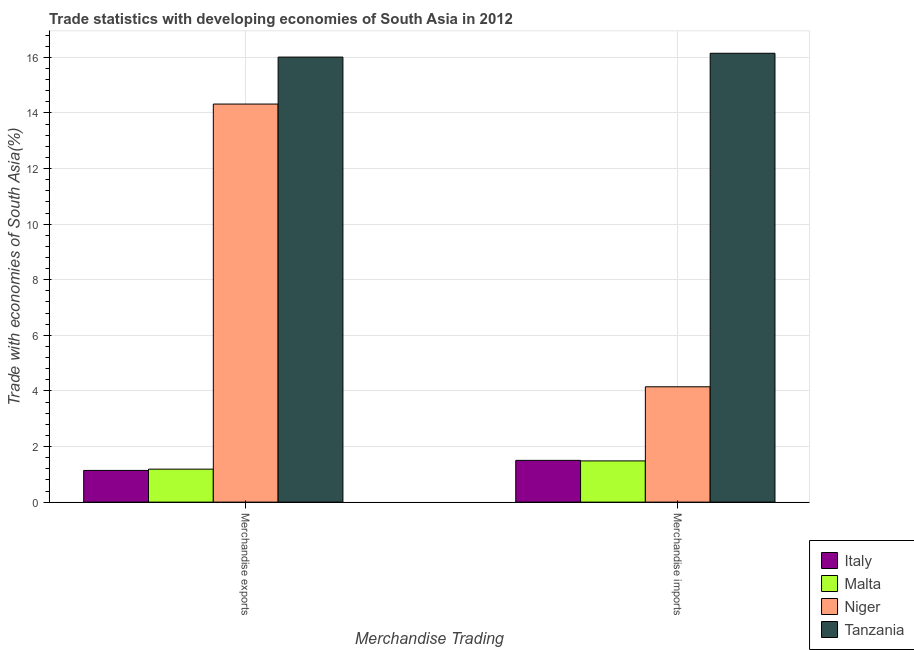How many different coloured bars are there?
Your response must be concise. 4. How many groups of bars are there?
Make the answer very short. 2. Are the number of bars per tick equal to the number of legend labels?
Give a very brief answer. Yes. Are the number of bars on each tick of the X-axis equal?
Give a very brief answer. Yes. How many bars are there on the 2nd tick from the left?
Offer a terse response. 4. How many bars are there on the 2nd tick from the right?
Offer a very short reply. 4. What is the merchandise exports in Tanzania?
Your answer should be very brief. 16.01. Across all countries, what is the maximum merchandise exports?
Provide a succinct answer. 16.01. Across all countries, what is the minimum merchandise exports?
Provide a short and direct response. 1.14. In which country was the merchandise imports maximum?
Your answer should be very brief. Tanzania. In which country was the merchandise imports minimum?
Offer a terse response. Malta. What is the total merchandise exports in the graph?
Provide a succinct answer. 32.66. What is the difference between the merchandise imports in Tanzania and that in Niger?
Keep it short and to the point. 12. What is the difference between the merchandise exports in Niger and the merchandise imports in Tanzania?
Keep it short and to the point. -1.83. What is the average merchandise imports per country?
Your response must be concise. 5.82. What is the difference between the merchandise exports and merchandise imports in Tanzania?
Ensure brevity in your answer.  -0.14. In how many countries, is the merchandise exports greater than 6.8 %?
Make the answer very short. 2. What is the ratio of the merchandise imports in Tanzania to that in Malta?
Provide a succinct answer. 10.89. In how many countries, is the merchandise imports greater than the average merchandise imports taken over all countries?
Provide a short and direct response. 1. What does the 4th bar from the left in Merchandise imports represents?
Offer a very short reply. Tanzania. What does the 3rd bar from the right in Merchandise exports represents?
Keep it short and to the point. Malta. What is the difference between two consecutive major ticks on the Y-axis?
Offer a terse response. 2. Are the values on the major ticks of Y-axis written in scientific E-notation?
Offer a terse response. No. Does the graph contain any zero values?
Make the answer very short. No. Does the graph contain grids?
Make the answer very short. Yes. How many legend labels are there?
Your answer should be very brief. 4. How are the legend labels stacked?
Offer a terse response. Vertical. What is the title of the graph?
Make the answer very short. Trade statistics with developing economies of South Asia in 2012. Does "Azerbaijan" appear as one of the legend labels in the graph?
Offer a terse response. No. What is the label or title of the X-axis?
Offer a very short reply. Merchandise Trading. What is the label or title of the Y-axis?
Offer a very short reply. Trade with economies of South Asia(%). What is the Trade with economies of South Asia(%) of Italy in Merchandise exports?
Give a very brief answer. 1.14. What is the Trade with economies of South Asia(%) in Malta in Merchandise exports?
Your response must be concise. 1.19. What is the Trade with economies of South Asia(%) of Niger in Merchandise exports?
Provide a short and direct response. 14.32. What is the Trade with economies of South Asia(%) in Tanzania in Merchandise exports?
Give a very brief answer. 16.01. What is the Trade with economies of South Asia(%) of Italy in Merchandise imports?
Ensure brevity in your answer.  1.5. What is the Trade with economies of South Asia(%) in Malta in Merchandise imports?
Make the answer very short. 1.48. What is the Trade with economies of South Asia(%) of Niger in Merchandise imports?
Offer a very short reply. 4.15. What is the Trade with economies of South Asia(%) of Tanzania in Merchandise imports?
Keep it short and to the point. 16.15. Across all Merchandise Trading, what is the maximum Trade with economies of South Asia(%) of Italy?
Ensure brevity in your answer.  1.5. Across all Merchandise Trading, what is the maximum Trade with economies of South Asia(%) of Malta?
Your response must be concise. 1.48. Across all Merchandise Trading, what is the maximum Trade with economies of South Asia(%) of Niger?
Provide a short and direct response. 14.32. Across all Merchandise Trading, what is the maximum Trade with economies of South Asia(%) in Tanzania?
Provide a succinct answer. 16.15. Across all Merchandise Trading, what is the minimum Trade with economies of South Asia(%) in Italy?
Provide a short and direct response. 1.14. Across all Merchandise Trading, what is the minimum Trade with economies of South Asia(%) of Malta?
Offer a terse response. 1.19. Across all Merchandise Trading, what is the minimum Trade with economies of South Asia(%) of Niger?
Keep it short and to the point. 4.15. Across all Merchandise Trading, what is the minimum Trade with economies of South Asia(%) in Tanzania?
Offer a terse response. 16.01. What is the total Trade with economies of South Asia(%) in Italy in the graph?
Offer a very short reply. 2.64. What is the total Trade with economies of South Asia(%) in Malta in the graph?
Your response must be concise. 2.67. What is the total Trade with economies of South Asia(%) of Niger in the graph?
Make the answer very short. 18.47. What is the total Trade with economies of South Asia(%) of Tanzania in the graph?
Make the answer very short. 32.16. What is the difference between the Trade with economies of South Asia(%) in Italy in Merchandise exports and that in Merchandise imports?
Keep it short and to the point. -0.36. What is the difference between the Trade with economies of South Asia(%) in Malta in Merchandise exports and that in Merchandise imports?
Ensure brevity in your answer.  -0.3. What is the difference between the Trade with economies of South Asia(%) in Niger in Merchandise exports and that in Merchandise imports?
Give a very brief answer. 10.17. What is the difference between the Trade with economies of South Asia(%) in Tanzania in Merchandise exports and that in Merchandise imports?
Your answer should be very brief. -0.14. What is the difference between the Trade with economies of South Asia(%) of Italy in Merchandise exports and the Trade with economies of South Asia(%) of Malta in Merchandise imports?
Provide a succinct answer. -0.34. What is the difference between the Trade with economies of South Asia(%) in Italy in Merchandise exports and the Trade with economies of South Asia(%) in Niger in Merchandise imports?
Your answer should be very brief. -3.01. What is the difference between the Trade with economies of South Asia(%) in Italy in Merchandise exports and the Trade with economies of South Asia(%) in Tanzania in Merchandise imports?
Make the answer very short. -15.01. What is the difference between the Trade with economies of South Asia(%) in Malta in Merchandise exports and the Trade with economies of South Asia(%) in Niger in Merchandise imports?
Offer a terse response. -2.96. What is the difference between the Trade with economies of South Asia(%) of Malta in Merchandise exports and the Trade with economies of South Asia(%) of Tanzania in Merchandise imports?
Give a very brief answer. -14.96. What is the difference between the Trade with economies of South Asia(%) in Niger in Merchandise exports and the Trade with economies of South Asia(%) in Tanzania in Merchandise imports?
Keep it short and to the point. -1.83. What is the average Trade with economies of South Asia(%) of Italy per Merchandise Trading?
Ensure brevity in your answer.  1.32. What is the average Trade with economies of South Asia(%) in Malta per Merchandise Trading?
Your answer should be very brief. 1.33. What is the average Trade with economies of South Asia(%) in Niger per Merchandise Trading?
Your response must be concise. 9.24. What is the average Trade with economies of South Asia(%) of Tanzania per Merchandise Trading?
Your response must be concise. 16.08. What is the difference between the Trade with economies of South Asia(%) of Italy and Trade with economies of South Asia(%) of Malta in Merchandise exports?
Offer a very short reply. -0.05. What is the difference between the Trade with economies of South Asia(%) of Italy and Trade with economies of South Asia(%) of Niger in Merchandise exports?
Offer a very short reply. -13.18. What is the difference between the Trade with economies of South Asia(%) in Italy and Trade with economies of South Asia(%) in Tanzania in Merchandise exports?
Your response must be concise. -14.87. What is the difference between the Trade with economies of South Asia(%) of Malta and Trade with economies of South Asia(%) of Niger in Merchandise exports?
Give a very brief answer. -13.13. What is the difference between the Trade with economies of South Asia(%) in Malta and Trade with economies of South Asia(%) in Tanzania in Merchandise exports?
Your answer should be compact. -14.82. What is the difference between the Trade with economies of South Asia(%) of Niger and Trade with economies of South Asia(%) of Tanzania in Merchandise exports?
Your response must be concise. -1.69. What is the difference between the Trade with economies of South Asia(%) of Italy and Trade with economies of South Asia(%) of Malta in Merchandise imports?
Keep it short and to the point. 0.02. What is the difference between the Trade with economies of South Asia(%) of Italy and Trade with economies of South Asia(%) of Niger in Merchandise imports?
Keep it short and to the point. -2.65. What is the difference between the Trade with economies of South Asia(%) of Italy and Trade with economies of South Asia(%) of Tanzania in Merchandise imports?
Keep it short and to the point. -14.65. What is the difference between the Trade with economies of South Asia(%) of Malta and Trade with economies of South Asia(%) of Niger in Merchandise imports?
Give a very brief answer. -2.67. What is the difference between the Trade with economies of South Asia(%) of Malta and Trade with economies of South Asia(%) of Tanzania in Merchandise imports?
Keep it short and to the point. -14.66. What is the difference between the Trade with economies of South Asia(%) of Niger and Trade with economies of South Asia(%) of Tanzania in Merchandise imports?
Provide a succinct answer. -12. What is the ratio of the Trade with economies of South Asia(%) of Italy in Merchandise exports to that in Merchandise imports?
Keep it short and to the point. 0.76. What is the ratio of the Trade with economies of South Asia(%) of Malta in Merchandise exports to that in Merchandise imports?
Provide a short and direct response. 0.8. What is the ratio of the Trade with economies of South Asia(%) of Niger in Merchandise exports to that in Merchandise imports?
Provide a short and direct response. 3.45. What is the ratio of the Trade with economies of South Asia(%) of Tanzania in Merchandise exports to that in Merchandise imports?
Provide a succinct answer. 0.99. What is the difference between the highest and the second highest Trade with economies of South Asia(%) of Italy?
Keep it short and to the point. 0.36. What is the difference between the highest and the second highest Trade with economies of South Asia(%) in Malta?
Offer a very short reply. 0.3. What is the difference between the highest and the second highest Trade with economies of South Asia(%) of Niger?
Give a very brief answer. 10.17. What is the difference between the highest and the second highest Trade with economies of South Asia(%) of Tanzania?
Provide a succinct answer. 0.14. What is the difference between the highest and the lowest Trade with economies of South Asia(%) in Italy?
Ensure brevity in your answer.  0.36. What is the difference between the highest and the lowest Trade with economies of South Asia(%) in Malta?
Your answer should be compact. 0.3. What is the difference between the highest and the lowest Trade with economies of South Asia(%) of Niger?
Offer a very short reply. 10.17. What is the difference between the highest and the lowest Trade with economies of South Asia(%) in Tanzania?
Offer a terse response. 0.14. 